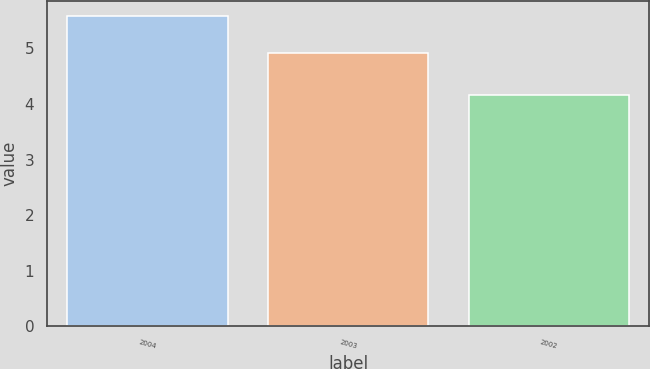Convert chart. <chart><loc_0><loc_0><loc_500><loc_500><bar_chart><fcel>2004<fcel>2003<fcel>2002<nl><fcel>5.58<fcel>4.92<fcel>4.17<nl></chart> 